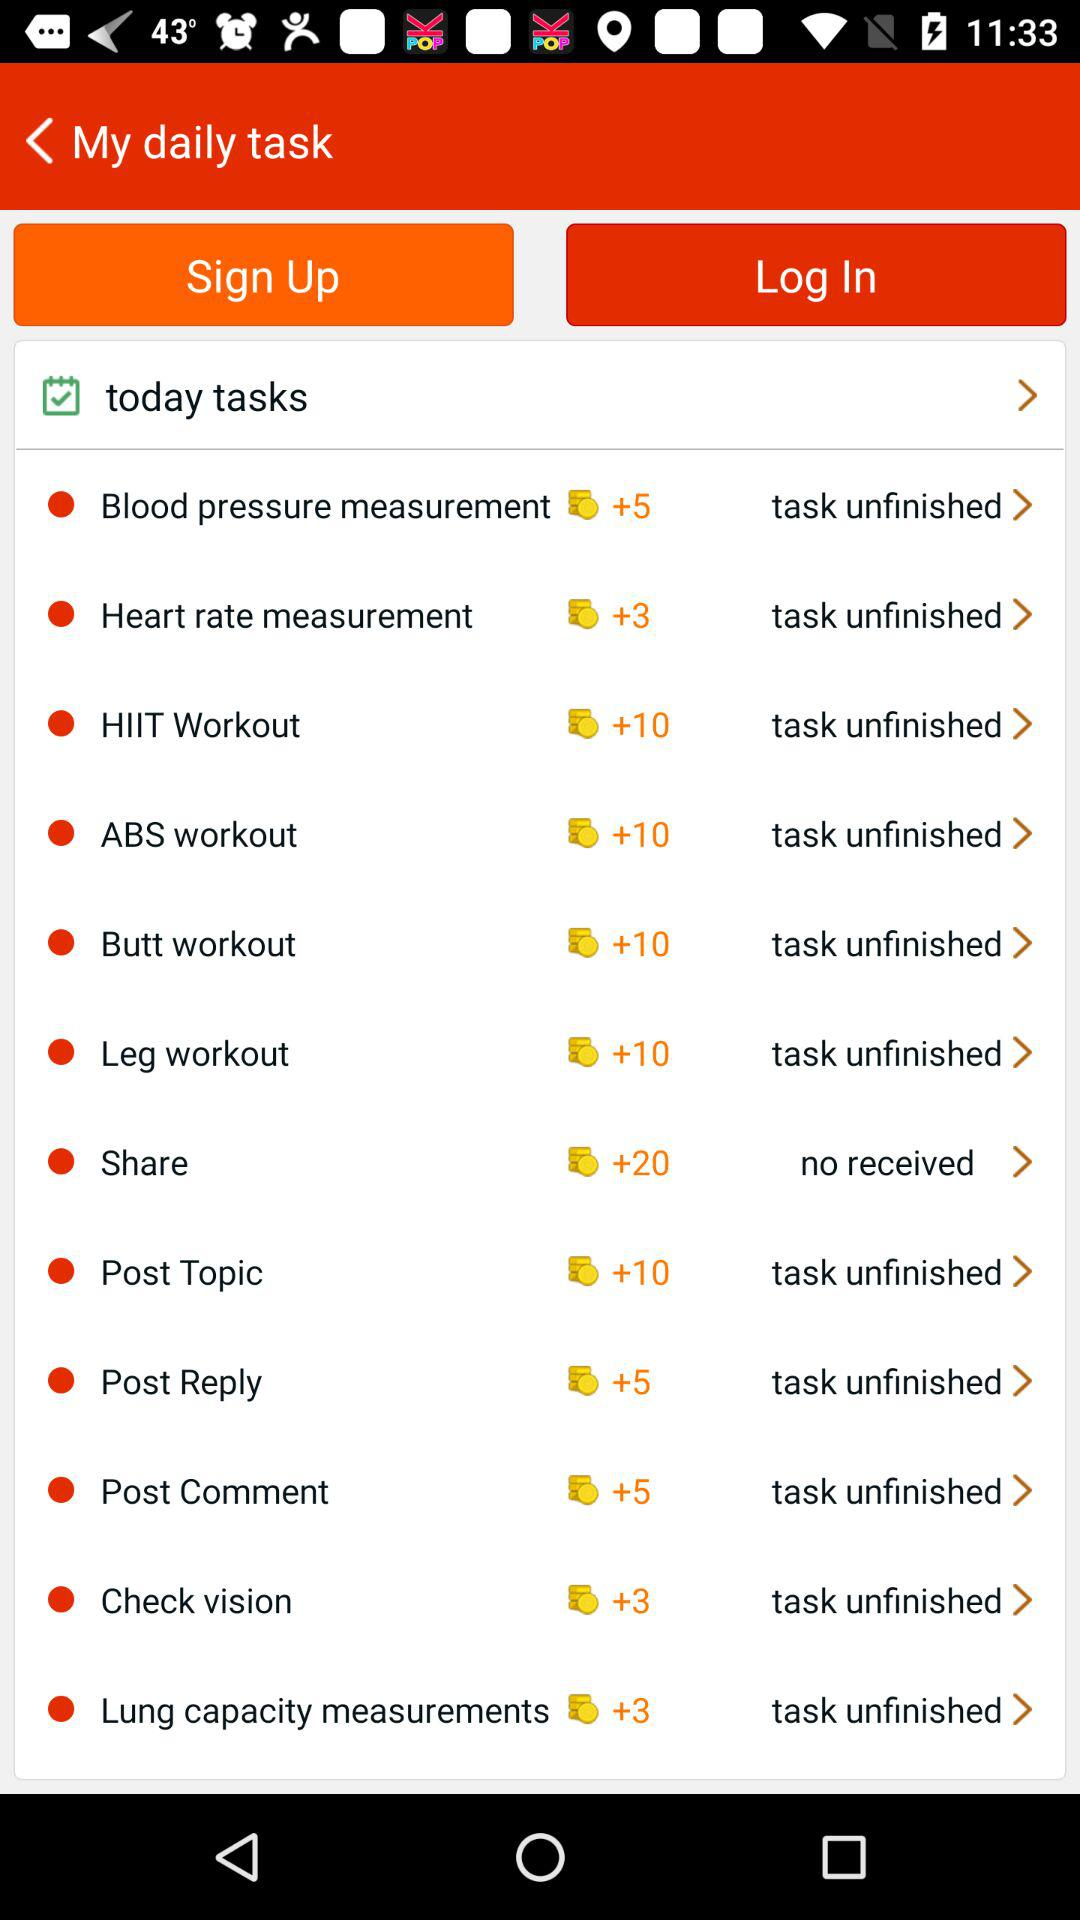What are the tasks scheduled for today? The scheduled tasks are "Blood pressure measurement", "Heart rate measurement", "HIIT Workout", "ABS workout", "Butt workout", "Leg workout", "Share", "Post Topic", "Post Reply", "Post Comment", "Check vision" and "Lung capacity measurements". 